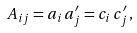<formula> <loc_0><loc_0><loc_500><loc_500>A _ { i j } = a _ { i } \, a ^ { \prime } _ { j } = c _ { i } \, c ^ { \prime } _ { j } \, ,</formula> 